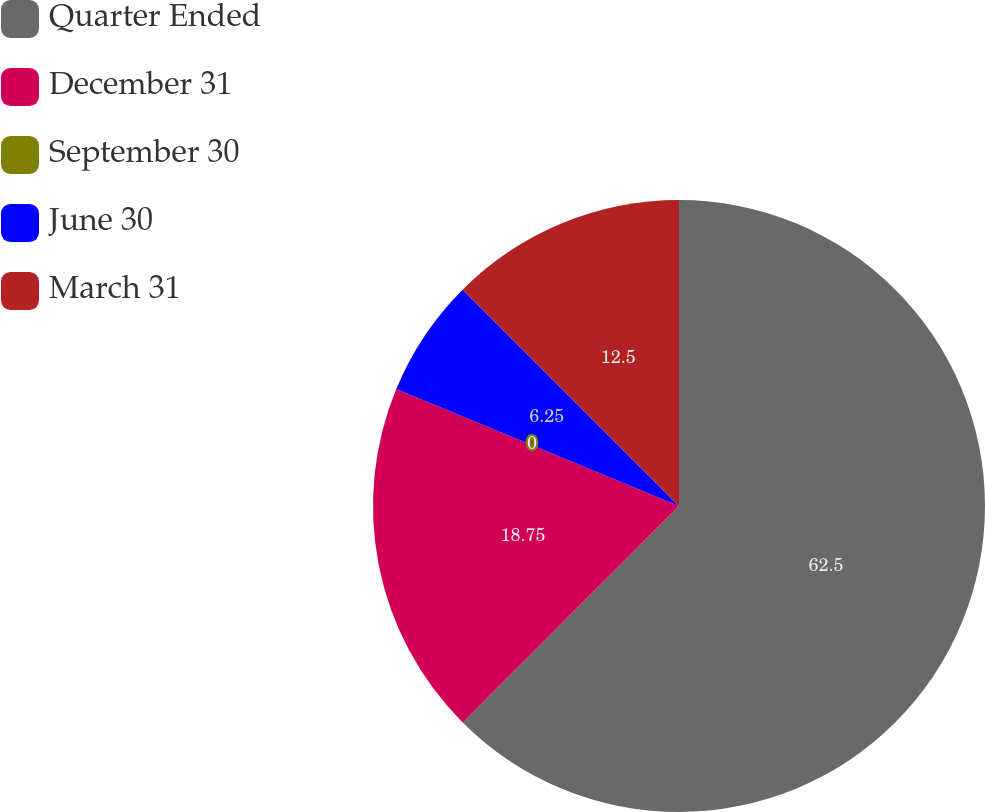Convert chart to OTSL. <chart><loc_0><loc_0><loc_500><loc_500><pie_chart><fcel>Quarter Ended<fcel>December 31<fcel>September 30<fcel>June 30<fcel>March 31<nl><fcel>62.49%<fcel>18.75%<fcel>0.0%<fcel>6.25%<fcel>12.5%<nl></chart> 